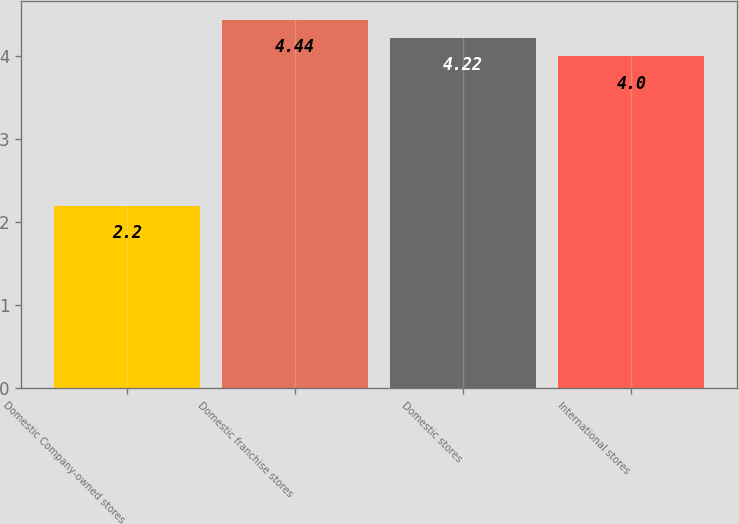Convert chart. <chart><loc_0><loc_0><loc_500><loc_500><bar_chart><fcel>Domestic Company-owned stores<fcel>Domestic franchise stores<fcel>Domestic stores<fcel>International stores<nl><fcel>2.2<fcel>4.44<fcel>4.22<fcel>4<nl></chart> 